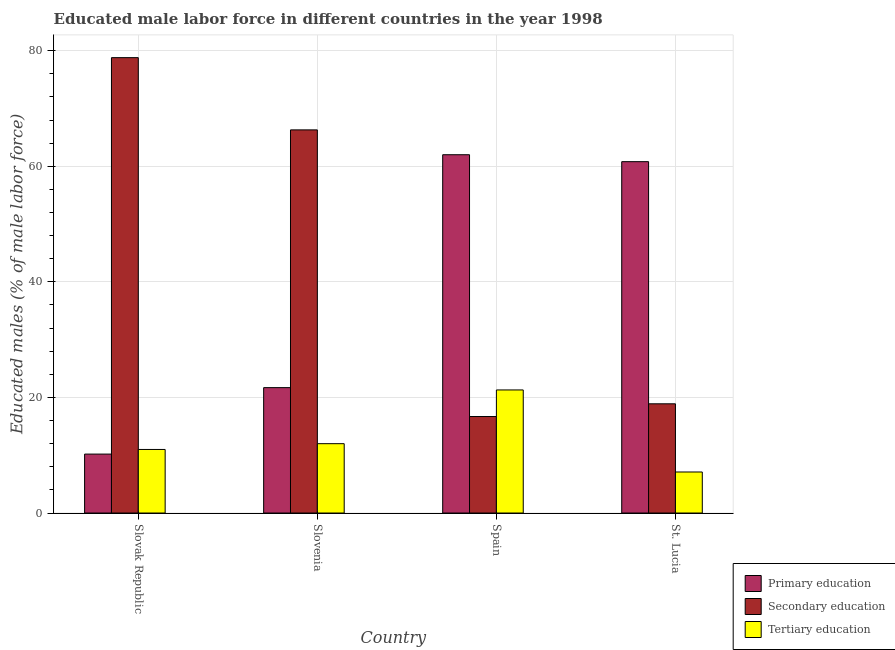How many groups of bars are there?
Offer a very short reply. 4. Are the number of bars per tick equal to the number of legend labels?
Offer a very short reply. Yes. How many bars are there on the 2nd tick from the left?
Ensure brevity in your answer.  3. How many bars are there on the 4th tick from the right?
Provide a succinct answer. 3. What is the label of the 4th group of bars from the left?
Your answer should be compact. St. Lucia. Across all countries, what is the maximum percentage of male labor force who received tertiary education?
Offer a very short reply. 21.3. Across all countries, what is the minimum percentage of male labor force who received primary education?
Provide a succinct answer. 10.2. In which country was the percentage of male labor force who received tertiary education maximum?
Offer a very short reply. Spain. In which country was the percentage of male labor force who received tertiary education minimum?
Your response must be concise. St. Lucia. What is the total percentage of male labor force who received primary education in the graph?
Your answer should be compact. 154.7. What is the difference between the percentage of male labor force who received tertiary education in Slovenia and that in Spain?
Make the answer very short. -9.3. What is the difference between the percentage of male labor force who received tertiary education in Slovenia and the percentage of male labor force who received secondary education in Spain?
Give a very brief answer. -4.7. What is the average percentage of male labor force who received secondary education per country?
Offer a terse response. 45.18. What is the difference between the percentage of male labor force who received tertiary education and percentage of male labor force who received secondary education in Spain?
Ensure brevity in your answer.  4.6. What is the ratio of the percentage of male labor force who received tertiary education in Slovak Republic to that in St. Lucia?
Give a very brief answer. 1.55. Is the percentage of male labor force who received tertiary education in Slovak Republic less than that in Spain?
Offer a very short reply. Yes. Is the difference between the percentage of male labor force who received primary education in Slovenia and St. Lucia greater than the difference between the percentage of male labor force who received tertiary education in Slovenia and St. Lucia?
Make the answer very short. No. What is the difference between the highest and the lowest percentage of male labor force who received secondary education?
Offer a very short reply. 62.1. In how many countries, is the percentage of male labor force who received secondary education greater than the average percentage of male labor force who received secondary education taken over all countries?
Your answer should be compact. 2. Is the sum of the percentage of male labor force who received primary education in Slovak Republic and Spain greater than the maximum percentage of male labor force who received tertiary education across all countries?
Keep it short and to the point. Yes. What does the 2nd bar from the left in St. Lucia represents?
Give a very brief answer. Secondary education. What does the 1st bar from the right in St. Lucia represents?
Your answer should be compact. Tertiary education. Is it the case that in every country, the sum of the percentage of male labor force who received primary education and percentage of male labor force who received secondary education is greater than the percentage of male labor force who received tertiary education?
Give a very brief answer. Yes. How many bars are there?
Your answer should be very brief. 12. How many countries are there in the graph?
Provide a short and direct response. 4. What is the difference between two consecutive major ticks on the Y-axis?
Offer a very short reply. 20. Are the values on the major ticks of Y-axis written in scientific E-notation?
Offer a terse response. No. Where does the legend appear in the graph?
Make the answer very short. Bottom right. How many legend labels are there?
Give a very brief answer. 3. How are the legend labels stacked?
Make the answer very short. Vertical. What is the title of the graph?
Offer a very short reply. Educated male labor force in different countries in the year 1998. Does "Labor Tax" appear as one of the legend labels in the graph?
Offer a very short reply. No. What is the label or title of the Y-axis?
Make the answer very short. Educated males (% of male labor force). What is the Educated males (% of male labor force) of Primary education in Slovak Republic?
Give a very brief answer. 10.2. What is the Educated males (% of male labor force) of Secondary education in Slovak Republic?
Make the answer very short. 78.8. What is the Educated males (% of male labor force) in Primary education in Slovenia?
Provide a short and direct response. 21.7. What is the Educated males (% of male labor force) of Secondary education in Slovenia?
Ensure brevity in your answer.  66.3. What is the Educated males (% of male labor force) in Primary education in Spain?
Keep it short and to the point. 62. What is the Educated males (% of male labor force) of Secondary education in Spain?
Your response must be concise. 16.7. What is the Educated males (% of male labor force) in Tertiary education in Spain?
Keep it short and to the point. 21.3. What is the Educated males (% of male labor force) of Primary education in St. Lucia?
Offer a very short reply. 60.8. What is the Educated males (% of male labor force) in Secondary education in St. Lucia?
Your answer should be very brief. 18.9. What is the Educated males (% of male labor force) of Tertiary education in St. Lucia?
Give a very brief answer. 7.1. Across all countries, what is the maximum Educated males (% of male labor force) in Secondary education?
Ensure brevity in your answer.  78.8. Across all countries, what is the maximum Educated males (% of male labor force) in Tertiary education?
Your answer should be very brief. 21.3. Across all countries, what is the minimum Educated males (% of male labor force) of Primary education?
Your answer should be compact. 10.2. Across all countries, what is the minimum Educated males (% of male labor force) of Secondary education?
Your response must be concise. 16.7. Across all countries, what is the minimum Educated males (% of male labor force) in Tertiary education?
Keep it short and to the point. 7.1. What is the total Educated males (% of male labor force) of Primary education in the graph?
Your answer should be very brief. 154.7. What is the total Educated males (% of male labor force) of Secondary education in the graph?
Offer a terse response. 180.7. What is the total Educated males (% of male labor force) of Tertiary education in the graph?
Offer a very short reply. 51.4. What is the difference between the Educated males (% of male labor force) in Primary education in Slovak Republic and that in Spain?
Provide a succinct answer. -51.8. What is the difference between the Educated males (% of male labor force) of Secondary education in Slovak Republic and that in Spain?
Provide a short and direct response. 62.1. What is the difference between the Educated males (% of male labor force) in Primary education in Slovak Republic and that in St. Lucia?
Give a very brief answer. -50.6. What is the difference between the Educated males (% of male labor force) of Secondary education in Slovak Republic and that in St. Lucia?
Your answer should be compact. 59.9. What is the difference between the Educated males (% of male labor force) in Primary education in Slovenia and that in Spain?
Your answer should be compact. -40.3. What is the difference between the Educated males (% of male labor force) of Secondary education in Slovenia and that in Spain?
Provide a succinct answer. 49.6. What is the difference between the Educated males (% of male labor force) in Tertiary education in Slovenia and that in Spain?
Offer a very short reply. -9.3. What is the difference between the Educated males (% of male labor force) of Primary education in Slovenia and that in St. Lucia?
Give a very brief answer. -39.1. What is the difference between the Educated males (% of male labor force) in Secondary education in Slovenia and that in St. Lucia?
Offer a very short reply. 47.4. What is the difference between the Educated males (% of male labor force) in Secondary education in Spain and that in St. Lucia?
Make the answer very short. -2.2. What is the difference between the Educated males (% of male labor force) in Primary education in Slovak Republic and the Educated males (% of male labor force) in Secondary education in Slovenia?
Offer a very short reply. -56.1. What is the difference between the Educated males (% of male labor force) in Primary education in Slovak Republic and the Educated males (% of male labor force) in Tertiary education in Slovenia?
Give a very brief answer. -1.8. What is the difference between the Educated males (% of male labor force) of Secondary education in Slovak Republic and the Educated males (% of male labor force) of Tertiary education in Slovenia?
Provide a short and direct response. 66.8. What is the difference between the Educated males (% of male labor force) in Primary education in Slovak Republic and the Educated males (% of male labor force) in Secondary education in Spain?
Make the answer very short. -6.5. What is the difference between the Educated males (% of male labor force) of Primary education in Slovak Republic and the Educated males (% of male labor force) of Tertiary education in Spain?
Keep it short and to the point. -11.1. What is the difference between the Educated males (% of male labor force) of Secondary education in Slovak Republic and the Educated males (% of male labor force) of Tertiary education in Spain?
Provide a succinct answer. 57.5. What is the difference between the Educated males (% of male labor force) in Primary education in Slovak Republic and the Educated males (% of male labor force) in Secondary education in St. Lucia?
Offer a terse response. -8.7. What is the difference between the Educated males (% of male labor force) of Secondary education in Slovak Republic and the Educated males (% of male labor force) of Tertiary education in St. Lucia?
Ensure brevity in your answer.  71.7. What is the difference between the Educated males (% of male labor force) in Secondary education in Slovenia and the Educated males (% of male labor force) in Tertiary education in Spain?
Ensure brevity in your answer.  45. What is the difference between the Educated males (% of male labor force) in Primary education in Slovenia and the Educated males (% of male labor force) in Secondary education in St. Lucia?
Make the answer very short. 2.8. What is the difference between the Educated males (% of male labor force) in Primary education in Slovenia and the Educated males (% of male labor force) in Tertiary education in St. Lucia?
Your answer should be compact. 14.6. What is the difference between the Educated males (% of male labor force) of Secondary education in Slovenia and the Educated males (% of male labor force) of Tertiary education in St. Lucia?
Ensure brevity in your answer.  59.2. What is the difference between the Educated males (% of male labor force) in Primary education in Spain and the Educated males (% of male labor force) in Secondary education in St. Lucia?
Make the answer very short. 43.1. What is the difference between the Educated males (% of male labor force) of Primary education in Spain and the Educated males (% of male labor force) of Tertiary education in St. Lucia?
Provide a short and direct response. 54.9. What is the difference between the Educated males (% of male labor force) of Secondary education in Spain and the Educated males (% of male labor force) of Tertiary education in St. Lucia?
Ensure brevity in your answer.  9.6. What is the average Educated males (% of male labor force) of Primary education per country?
Ensure brevity in your answer.  38.67. What is the average Educated males (% of male labor force) of Secondary education per country?
Make the answer very short. 45.17. What is the average Educated males (% of male labor force) in Tertiary education per country?
Provide a succinct answer. 12.85. What is the difference between the Educated males (% of male labor force) in Primary education and Educated males (% of male labor force) in Secondary education in Slovak Republic?
Ensure brevity in your answer.  -68.6. What is the difference between the Educated males (% of male labor force) in Secondary education and Educated males (% of male labor force) in Tertiary education in Slovak Republic?
Keep it short and to the point. 67.8. What is the difference between the Educated males (% of male labor force) in Primary education and Educated males (% of male labor force) in Secondary education in Slovenia?
Provide a succinct answer. -44.6. What is the difference between the Educated males (% of male labor force) in Primary education and Educated males (% of male labor force) in Tertiary education in Slovenia?
Your answer should be very brief. 9.7. What is the difference between the Educated males (% of male labor force) in Secondary education and Educated males (% of male labor force) in Tertiary education in Slovenia?
Your answer should be compact. 54.3. What is the difference between the Educated males (% of male labor force) in Primary education and Educated males (% of male labor force) in Secondary education in Spain?
Provide a short and direct response. 45.3. What is the difference between the Educated males (% of male labor force) of Primary education and Educated males (% of male labor force) of Tertiary education in Spain?
Ensure brevity in your answer.  40.7. What is the difference between the Educated males (% of male labor force) in Secondary education and Educated males (% of male labor force) in Tertiary education in Spain?
Give a very brief answer. -4.6. What is the difference between the Educated males (% of male labor force) in Primary education and Educated males (% of male labor force) in Secondary education in St. Lucia?
Offer a very short reply. 41.9. What is the difference between the Educated males (% of male labor force) of Primary education and Educated males (% of male labor force) of Tertiary education in St. Lucia?
Provide a succinct answer. 53.7. What is the difference between the Educated males (% of male labor force) in Secondary education and Educated males (% of male labor force) in Tertiary education in St. Lucia?
Your answer should be compact. 11.8. What is the ratio of the Educated males (% of male labor force) in Primary education in Slovak Republic to that in Slovenia?
Offer a terse response. 0.47. What is the ratio of the Educated males (% of male labor force) in Secondary education in Slovak Republic to that in Slovenia?
Ensure brevity in your answer.  1.19. What is the ratio of the Educated males (% of male labor force) of Tertiary education in Slovak Republic to that in Slovenia?
Your answer should be very brief. 0.92. What is the ratio of the Educated males (% of male labor force) of Primary education in Slovak Republic to that in Spain?
Make the answer very short. 0.16. What is the ratio of the Educated males (% of male labor force) in Secondary education in Slovak Republic to that in Spain?
Your answer should be compact. 4.72. What is the ratio of the Educated males (% of male labor force) of Tertiary education in Slovak Republic to that in Spain?
Offer a terse response. 0.52. What is the ratio of the Educated males (% of male labor force) of Primary education in Slovak Republic to that in St. Lucia?
Ensure brevity in your answer.  0.17. What is the ratio of the Educated males (% of male labor force) of Secondary education in Slovak Republic to that in St. Lucia?
Your answer should be very brief. 4.17. What is the ratio of the Educated males (% of male labor force) of Tertiary education in Slovak Republic to that in St. Lucia?
Make the answer very short. 1.55. What is the ratio of the Educated males (% of male labor force) of Secondary education in Slovenia to that in Spain?
Your answer should be very brief. 3.97. What is the ratio of the Educated males (% of male labor force) of Tertiary education in Slovenia to that in Spain?
Make the answer very short. 0.56. What is the ratio of the Educated males (% of male labor force) in Primary education in Slovenia to that in St. Lucia?
Ensure brevity in your answer.  0.36. What is the ratio of the Educated males (% of male labor force) in Secondary education in Slovenia to that in St. Lucia?
Offer a terse response. 3.51. What is the ratio of the Educated males (% of male labor force) in Tertiary education in Slovenia to that in St. Lucia?
Provide a short and direct response. 1.69. What is the ratio of the Educated males (% of male labor force) in Primary education in Spain to that in St. Lucia?
Provide a short and direct response. 1.02. What is the ratio of the Educated males (% of male labor force) in Secondary education in Spain to that in St. Lucia?
Your answer should be very brief. 0.88. What is the ratio of the Educated males (% of male labor force) of Tertiary education in Spain to that in St. Lucia?
Provide a succinct answer. 3. What is the difference between the highest and the second highest Educated males (% of male labor force) of Primary education?
Provide a short and direct response. 1.2. What is the difference between the highest and the second highest Educated males (% of male labor force) of Tertiary education?
Offer a very short reply. 9.3. What is the difference between the highest and the lowest Educated males (% of male labor force) of Primary education?
Provide a short and direct response. 51.8. What is the difference between the highest and the lowest Educated males (% of male labor force) in Secondary education?
Provide a succinct answer. 62.1. What is the difference between the highest and the lowest Educated males (% of male labor force) of Tertiary education?
Your answer should be compact. 14.2. 